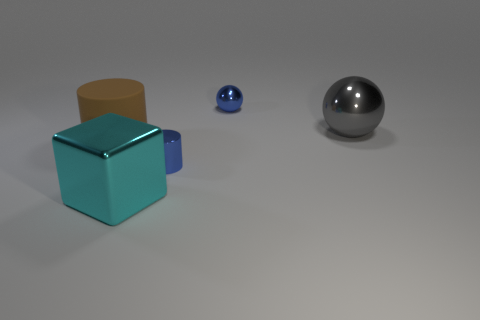Subtract all blue balls. How many balls are left? 1 Subtract all balls. How many objects are left? 3 Subtract all yellow balls. How many yellow blocks are left? 0 Add 3 cyan metal cubes. How many cyan metal cubes are left? 4 Add 3 big shiny things. How many big shiny things exist? 5 Add 5 large matte cubes. How many objects exist? 10 Subtract 0 yellow spheres. How many objects are left? 5 Subtract 2 cylinders. How many cylinders are left? 0 Subtract all brown cylinders. Subtract all brown balls. How many cylinders are left? 1 Subtract all large blue rubber cubes. Subtract all big gray spheres. How many objects are left? 4 